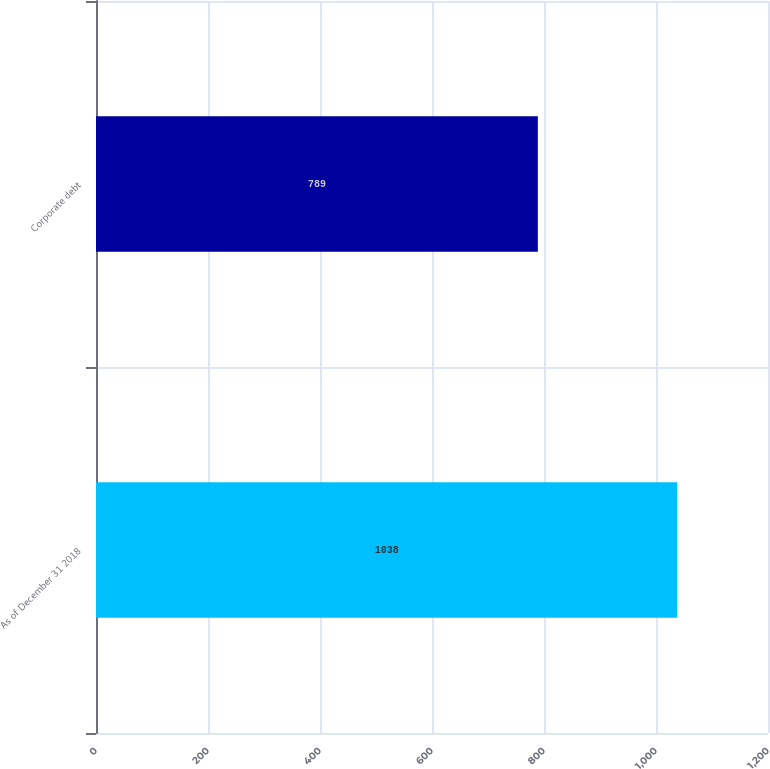Convert chart. <chart><loc_0><loc_0><loc_500><loc_500><bar_chart><fcel>As of December 31 2018<fcel>Corporate debt<nl><fcel>1038<fcel>789<nl></chart> 